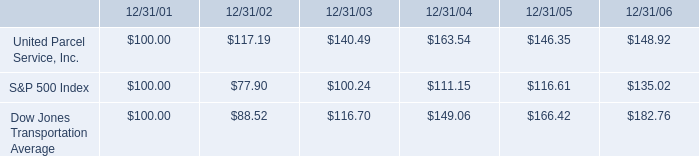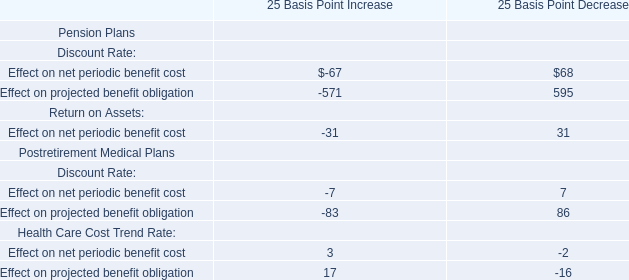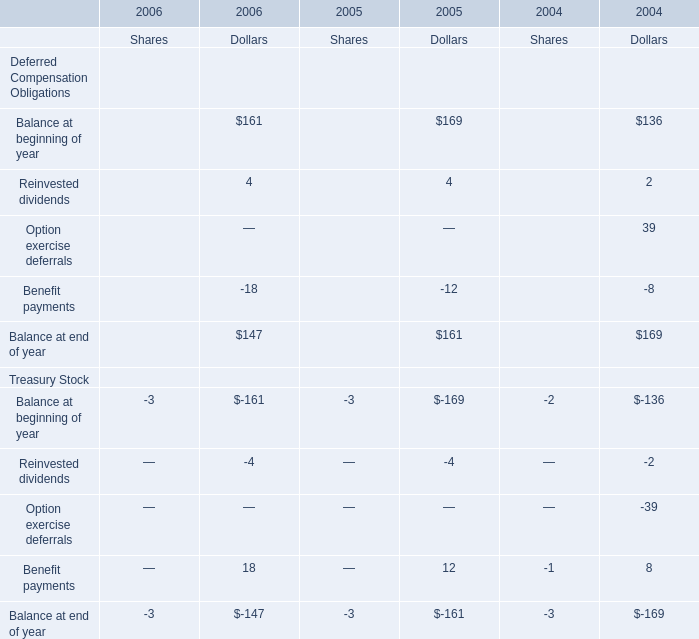Which year is Dollars for Balance at end of year for Deferred Compensation Obligations the largest? 
Answer: 2004. 